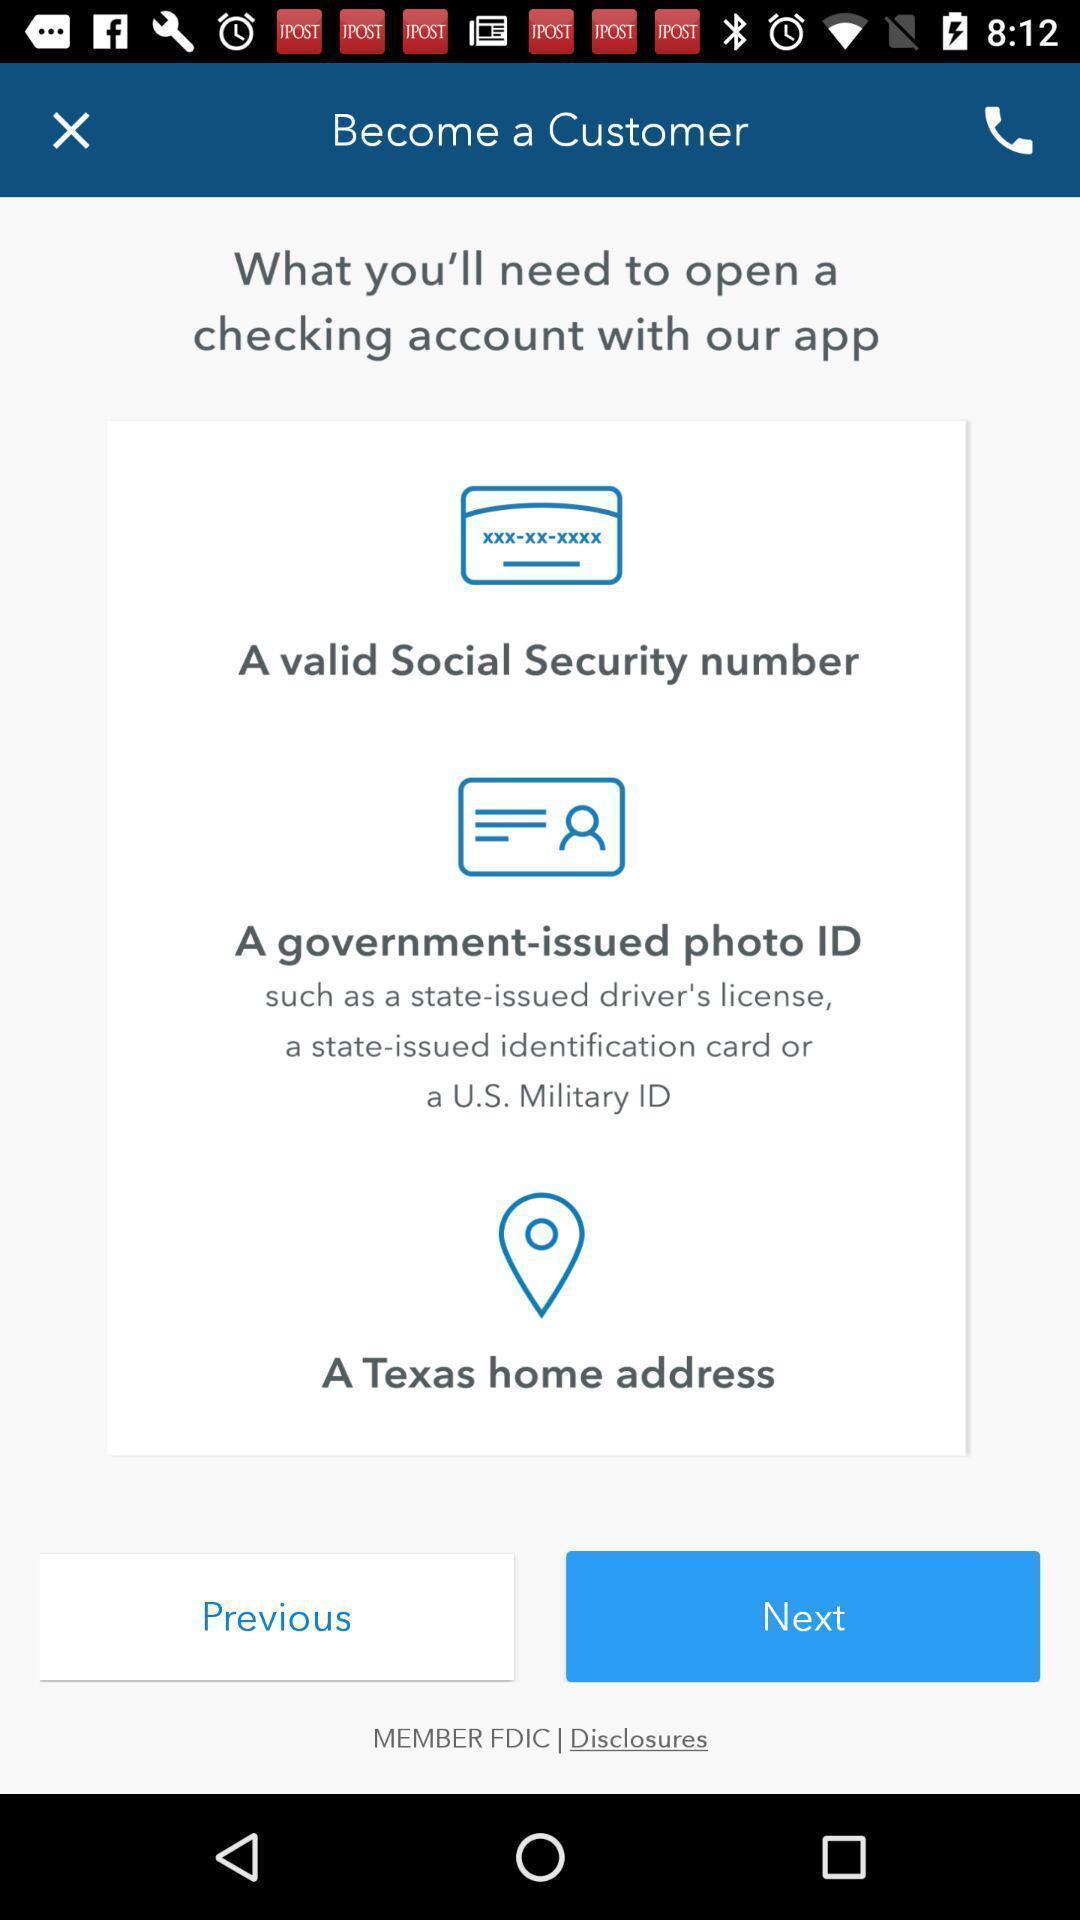Explain the elements present in this screenshot. Welcome page displayed to continue. 